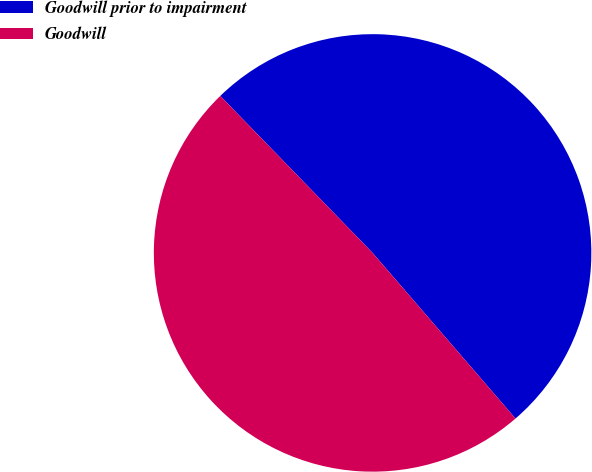Convert chart. <chart><loc_0><loc_0><loc_500><loc_500><pie_chart><fcel>Goodwill prior to impairment<fcel>Goodwill<nl><fcel>50.93%<fcel>49.07%<nl></chart> 